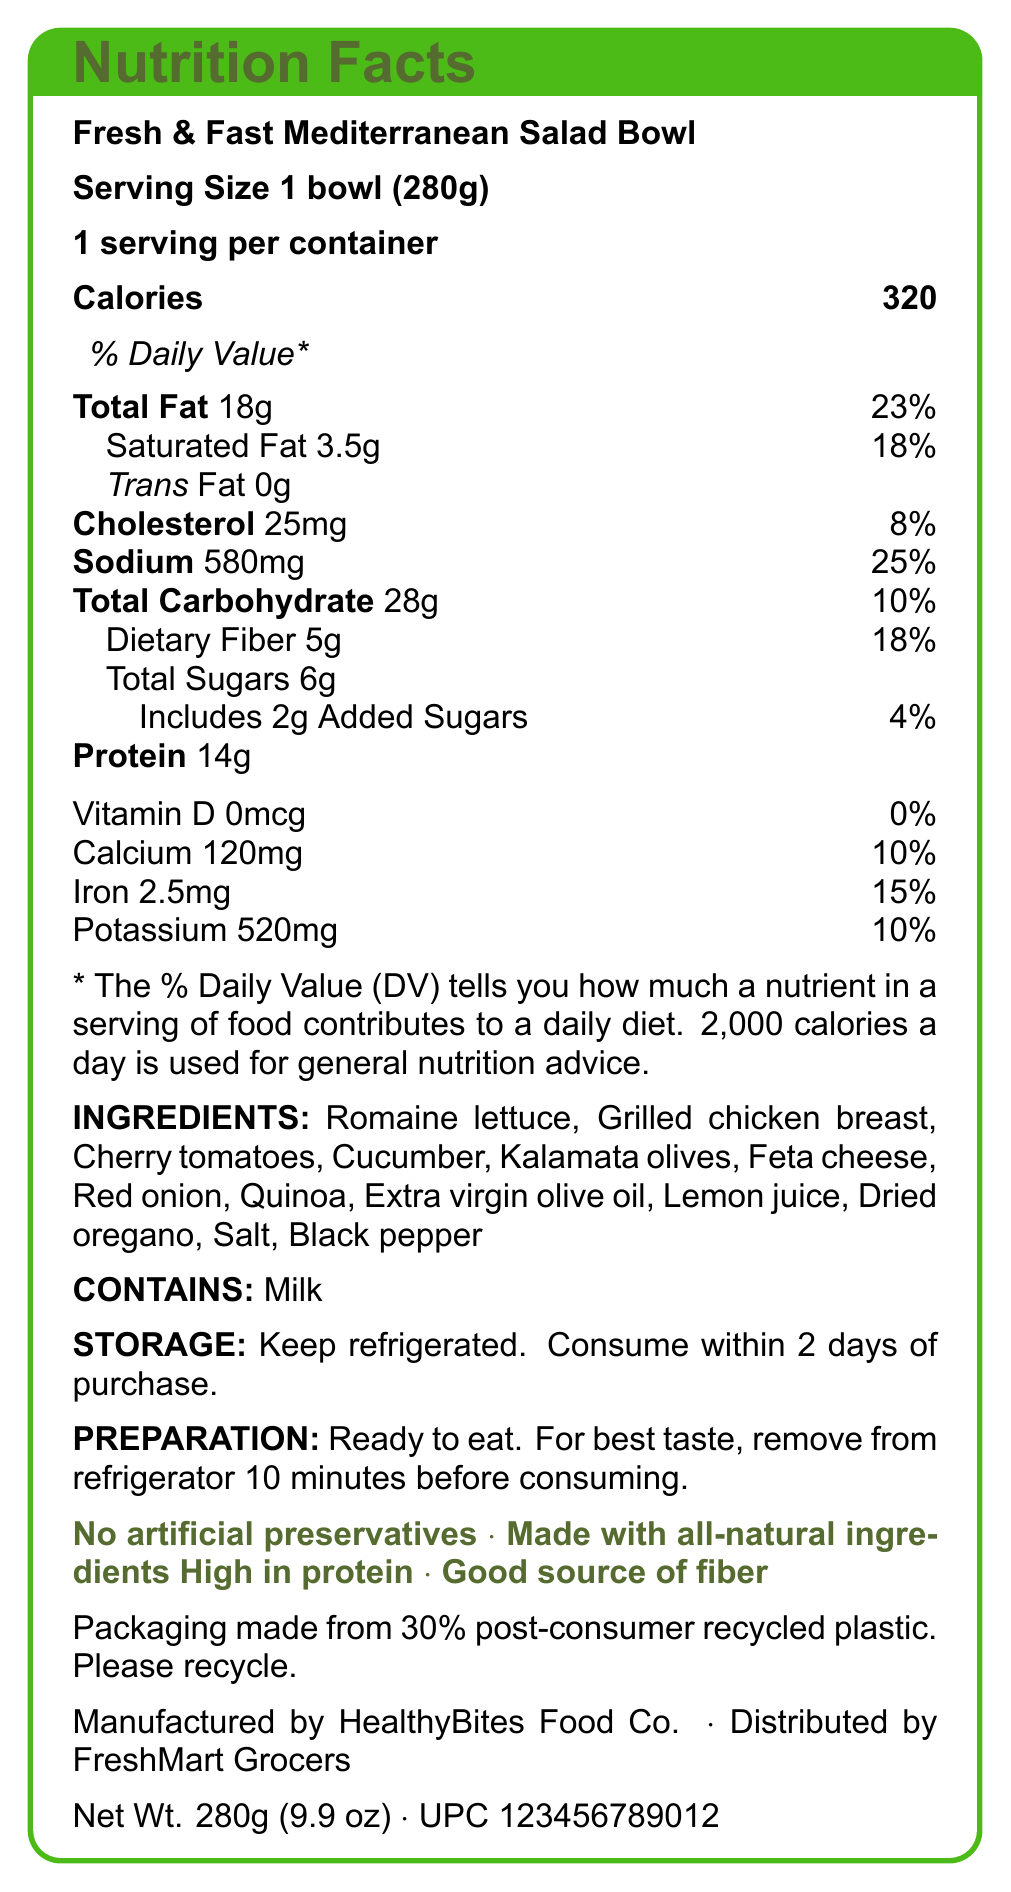what is the serving size? The serving size is specified at the top of the document as "Serving Size 1 bowl (280g)".
Answer: 1 bowl (280g) how many calories are in the entire salad bowl? The document lists "Calories 320" under the nutrition facts.
Answer: 320 what is the amount of sodium per serving? The amount of sodium per serving is specified as 580mg.
Answer: 580mg how much dietary fiber is in the salad bowl? The document states "Dietary Fiber 5g" under the nutrition facts.
Answer: 5g what should you do for best taste before consuming the salad? The preparation instructions state "For best taste, remove from refrigerator 10 minutes before consuming."
Answer: Remove from refrigerator 10 minutes before consuming which nutrient has the highest daily value percentage? A. Total Fat B. Sodium C. Total Carbohydrate D. Protein Total Fat has a daily value of 23%, which is higher than the daily values of Sodium (25%), Total Carbohydrate (10%), and Protein (not provided a percentage).
Answer: A. Total Fat what is the daily value percentage of calcium? A. 15% B. 10% C. 25% D. 18% According to the document, Calcium has a daily value percentage of 10%.
Answer: B. 10% does the salad contain any added sugars? The nutrition facts list "Includes 2g Added Sugars".
Answer: Yes can the salad be stored at room temperature? The storage instructions specify "Keep refrigerated."
Answer: No what allergens are present in the salad? The document specifies "CONTAINS: Milk" under allergens.
Answer: Milk does the product contain any trans fat? The nutrition facts label lists "Trans Fat 0g".
Answer: No who is the manufacturer of this salad? The document states "Manufactured by HealthyBites Food Co."
Answer: HealthyBites Food Co. describe the main idea of the document. The document is a comprehensive breakdown of the nutritional content and other important information about a pre-packaged salad, aiming to inform consumers about what they are eating and how to store and prepare the product.
Answer: The document provides the nutrition facts, ingredients, allergens, storage and preparation instructions, and other relevant information about the Fresh & Fast Mediterranean Salad Bowl. This includes details like serving size, daily value percentages for various nutrients, marketing claims, sustainability information, and manufacturer details. how many grams of protein are in the salad? The document states "Protein 14g".
Answer: 14g is the salad marketed as containing artificial preservatives? The marketing claims include "No artificial preservatives".
Answer: No what is the net weight of the salad in ounces? The document states the net weight as "280g (9.9 oz)".
Answer: 9.9 oz what sustainable practice is mentioned regarding the packaging? The sustainability information indicates the packaging is made from 30% post-consumer recycled plastic and requests that it be recycled.
Answer: Packaging made from 30% post-consumer recycled plastic. Please recycle. how many servings are in one container? The document specifies "1 serving per container".
Answer: 1 what percentage of daily value does the iron content cover? The document states "Iron 2.5mg (15%)".
Answer: 15% what type of meal is the salad marketed as? The document describes it as a pre-packaged salad marketed as a quick and healthy lunch option.
Answer: Quick and healthy lunch option does the salad include any meat? The ingredients list includes "Grilled chicken breast".
Answer: Yes can the exact brand of olive oil used be determined from the document? The document only specifies "Extra virgin olive oil" without mentioning a specific brand.
Answer: No 